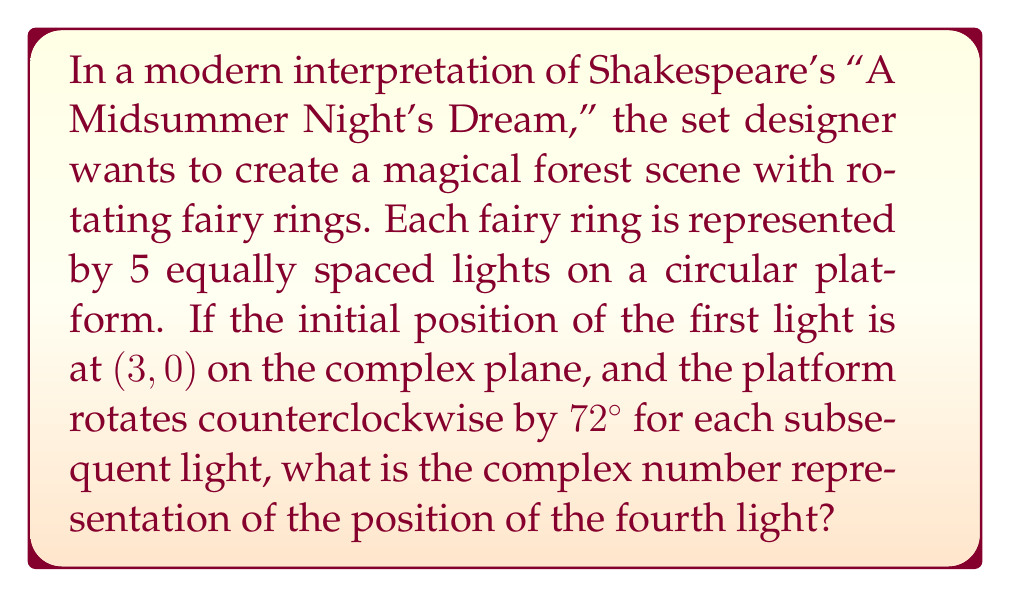Can you solve this math problem? Let's approach this step-by-step using De Moivre's theorem:

1) First, we need to express the rotation in terms of radians:
   $72° = \frac{72 \pi}{180} = \frac{2\pi}{5}$ radians

2) The initial position of the first light is $(3,0)$, which in complex form is $3 + 0i$ or simply $3$.

3) To rotate a point $z$ by an angle $\theta$, we multiply it by $e^{i\theta}$. In this case, we're rotating three times by $\frac{2\pi}{5}$ to get to the fourth light.

4) Using De Moivre's theorem, we can express this rotation as:

   $$(3) \cdot \left(e^{i\frac{2\pi}{5}}\right)^3 = 3 \cdot e^{i\frac{6\pi}{5}}$$

5) We can expand this using Euler's formula:
   $$3 \cdot e^{i\frac{6\pi}{5}} = 3 \cdot \left(\cos\frac{6\pi}{5} + i\sin\frac{6\pi}{5}\right)$$

6) Evaluating the trigonometric functions:
   $$3 \cdot \left(\cos\frac{6\pi}{5} + i\sin\frac{6\pi}{5}\right) = 3 \cdot \left(-\frac{\sqrt{5}+1}{4} + i\frac{\sqrt{5}-1}{4}\right)$$

7) Simplifying:
   $$= -\frac{3(\sqrt{5}+1)}{4} + i\frac{3(\sqrt{5}-1)}{4}$$
Answer: The complex number representation of the position of the fourth light is:

$$-\frac{3(\sqrt{5}+1)}{4} + i\frac{3(\sqrt{5}-1)}{4}$$ 